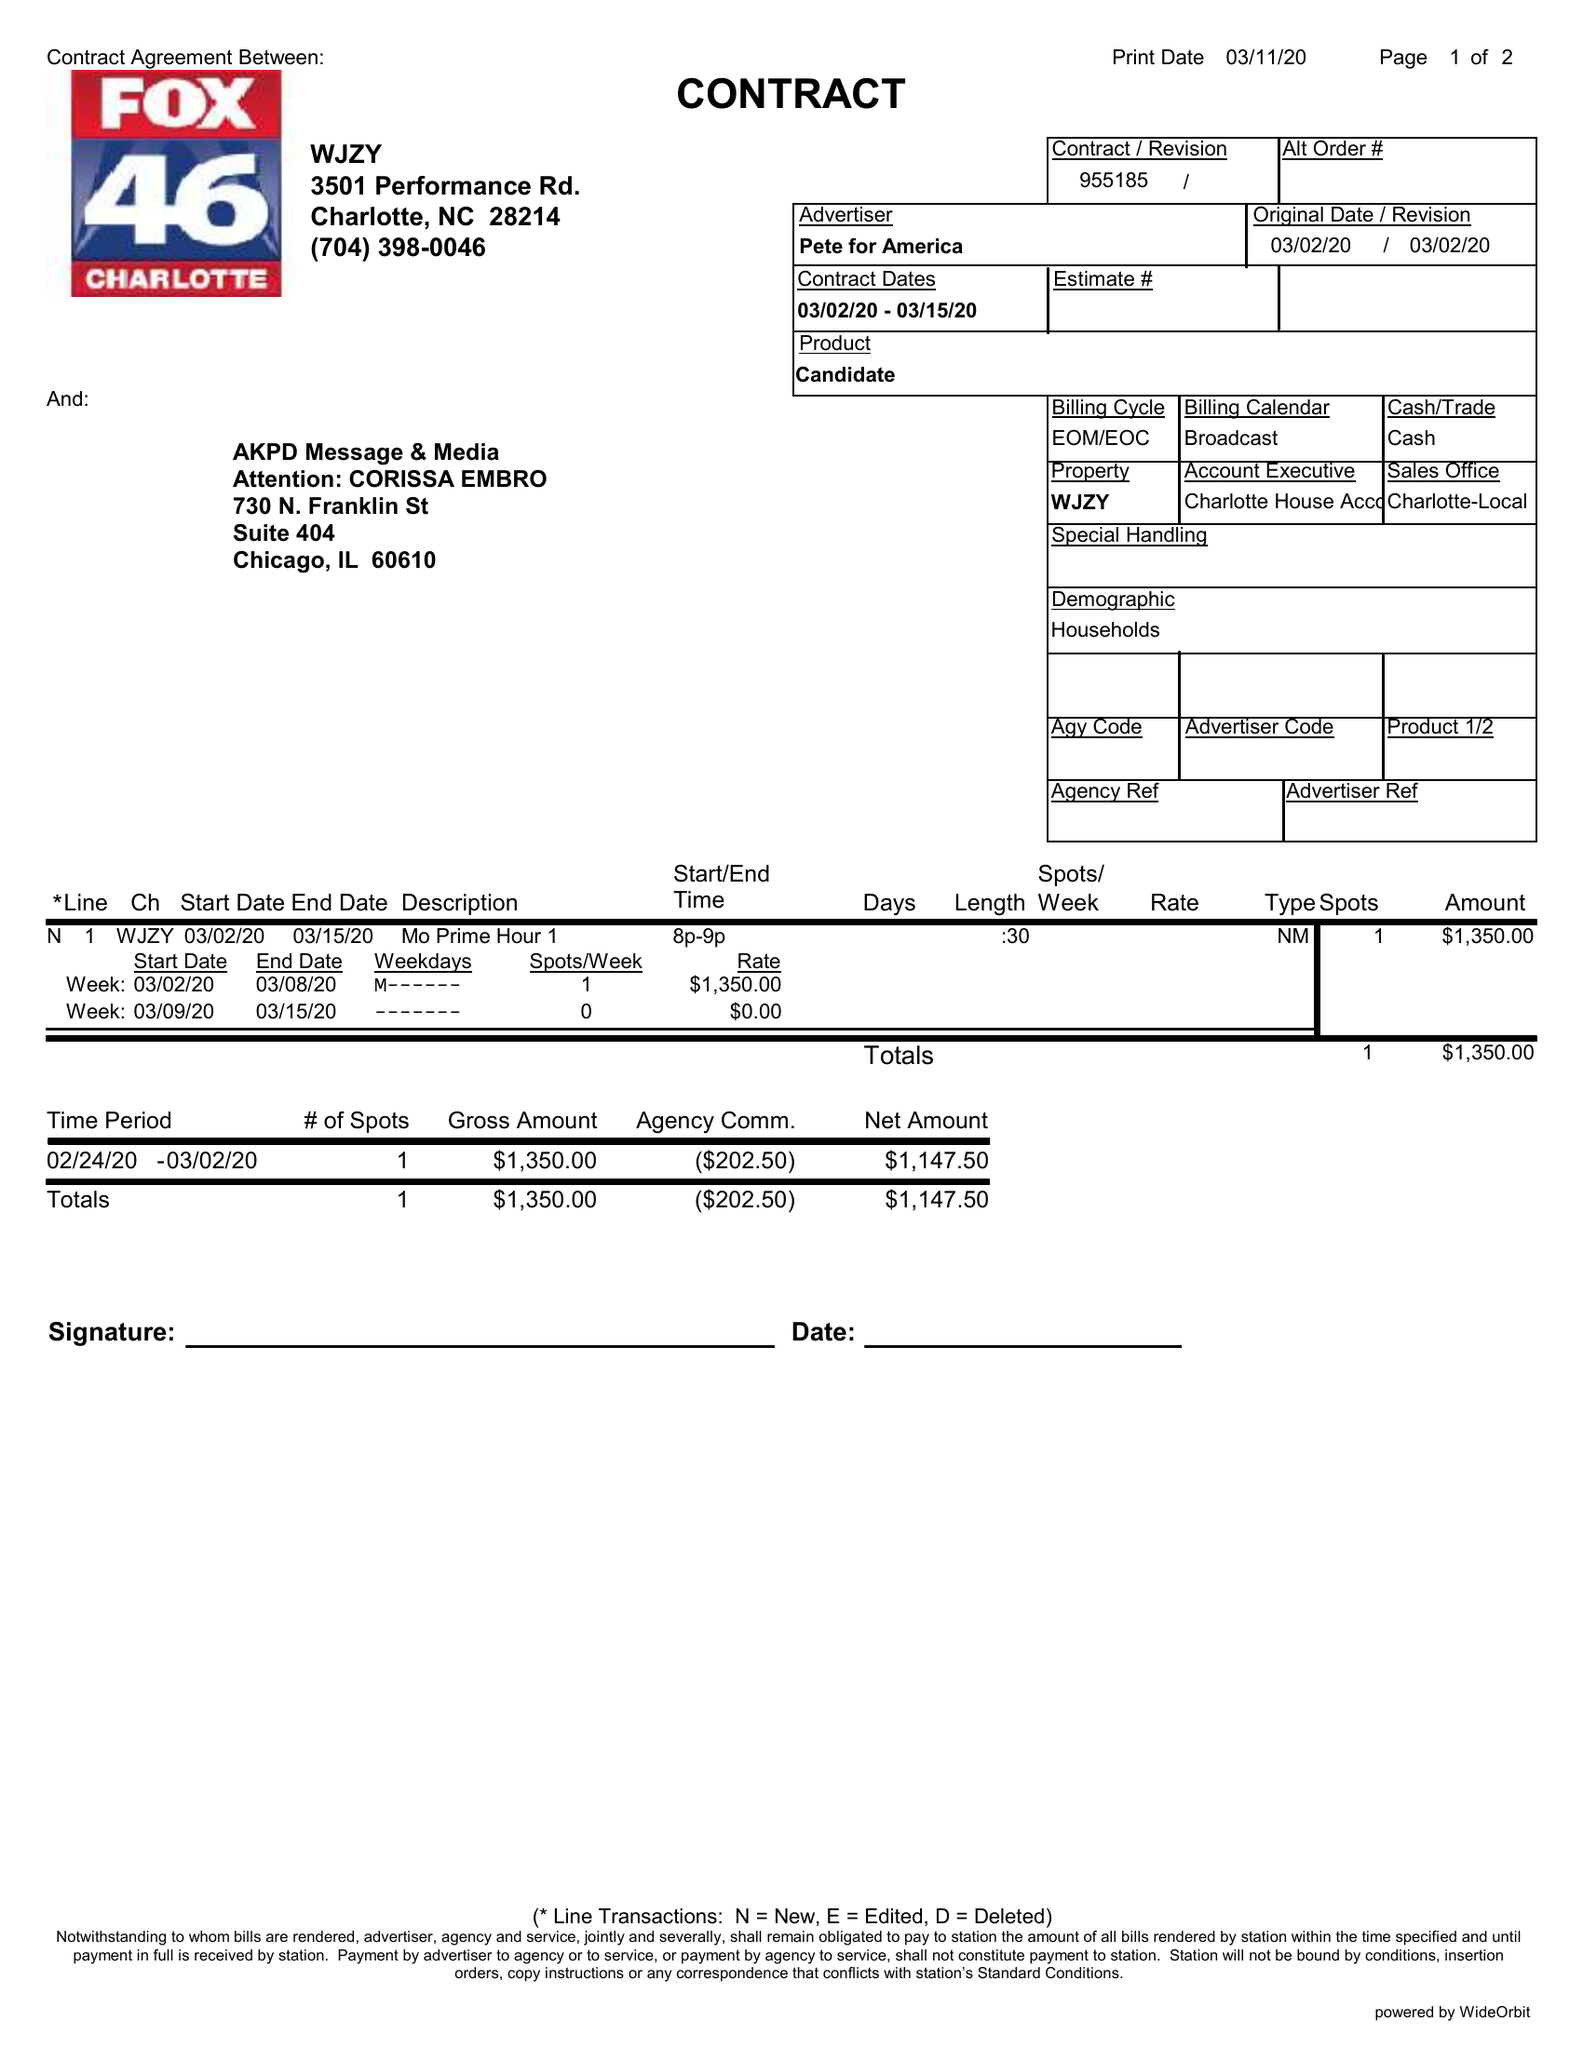What is the value for the advertiser?
Answer the question using a single word or phrase. PETE FOR AMERICA 